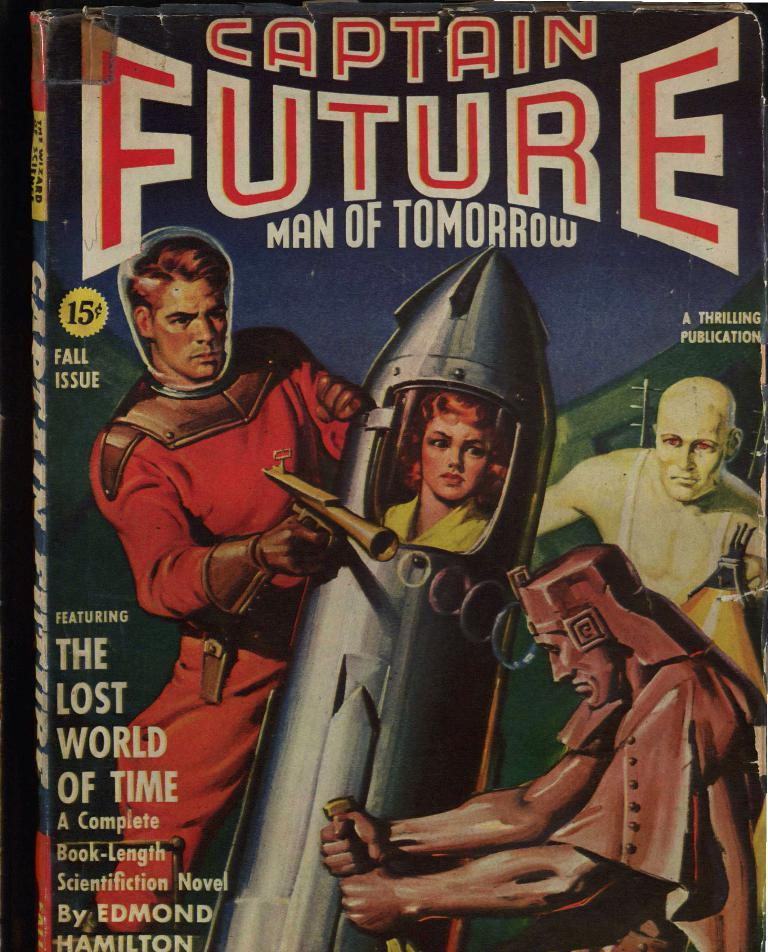<image>
Provide a brief description of the given image. The fall issue of Captain Future Man of Tomorrow is by Edmond Hamilton. 